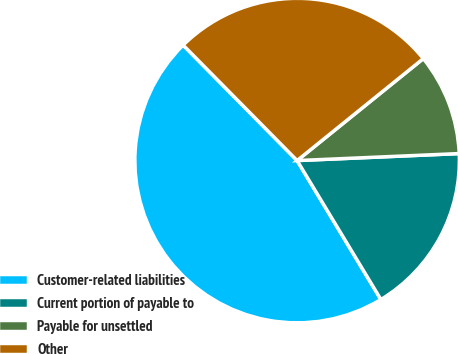Convert chart to OTSL. <chart><loc_0><loc_0><loc_500><loc_500><pie_chart><fcel>Customer-related liabilities<fcel>Current portion of payable to<fcel>Payable for unsettled<fcel>Other<nl><fcel>46.24%<fcel>17.05%<fcel>10.13%<fcel>26.58%<nl></chart> 